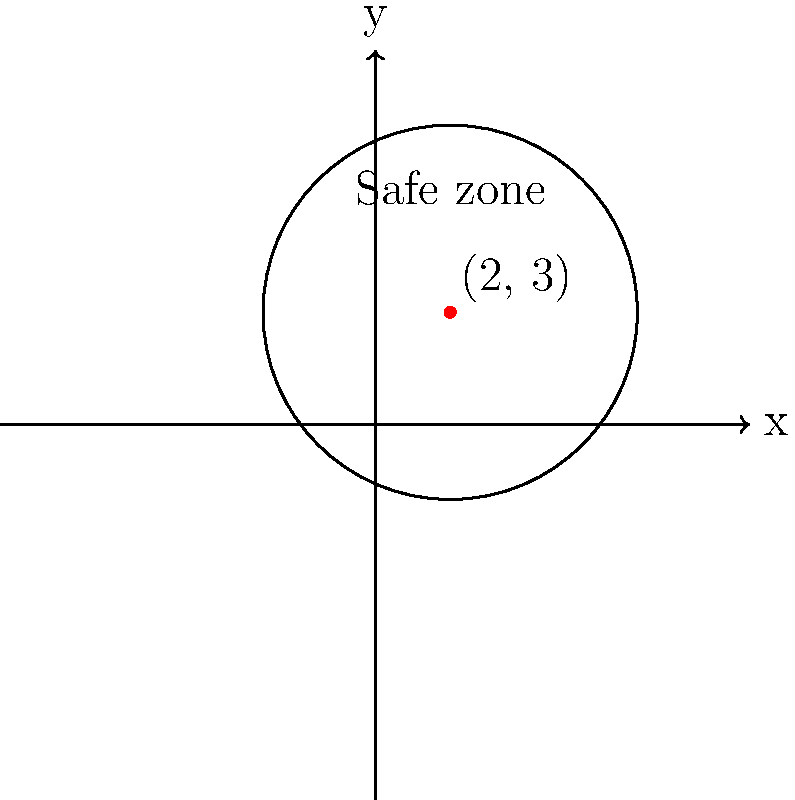As a parent concerned about your child's safety during their blogging adventures, you want to establish a safe zone around their current location. Your child is at the point (2, 3) on a map, and you want to create a circular safe zone with a radius of 5 units. What is the equation of the circle that represents this safe zone? To find the equation of the circle, we'll follow these steps:

1. Recall the general equation of a circle: $$(x - h)^2 + (y - k)^2 = r^2$$
   where (h, k) is the center of the circle and r is the radius.

2. Identify the given information:
   - Center of the circle (child's location): (h, k) = (2, 3)
   - Radius of the safe zone: r = 5

3. Substitute these values into the general equation:
   $$(x - 2)^2 + (y - 3)^2 = 5^2$$

4. Simplify the right side of the equation:
   $$(x - 2)^2 + (y - 3)^2 = 25$$

This is the final equation of the circle representing the safe zone.
Answer: $$(x - 2)^2 + (y - 3)^2 = 25$$ 